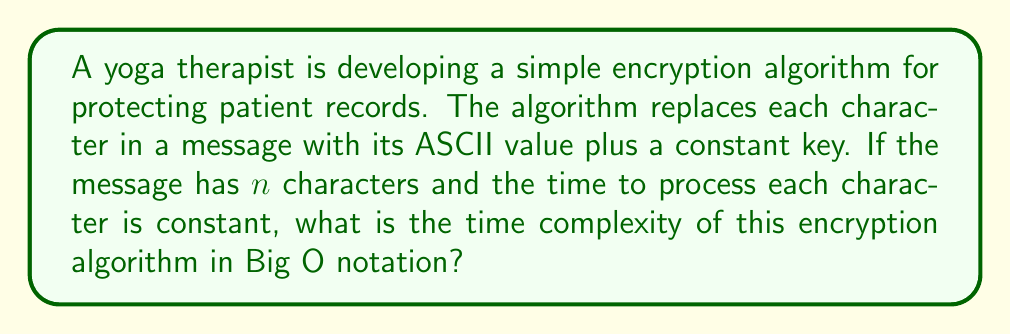Give your solution to this math problem. Let's analyze the algorithm step by step:

1. The algorithm processes each character in the message independently.
2. For each character, it performs a constant-time operation (adding the key to the ASCII value).
3. This operation is repeated for all $n$ characters in the message.

To determine the time complexity:

1. The number of operations is directly proportional to the number of characters ($n$) in the message.
2. Each operation takes constant time, let's call this time $c$.
3. The total time $T(n)$ can be expressed as:

   $$T(n) = c \cdot n$$

4. In Big O notation, we ignore constant factors. Therefore, the time complexity is:

   $$O(n)$$

This is because the time grows linearly with the input size $n$.
Answer: $O(n)$ 